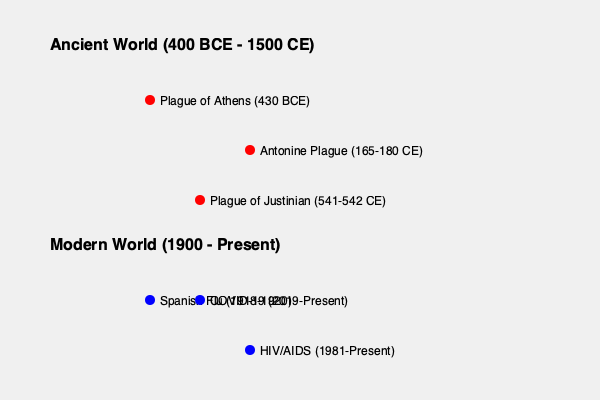Compare the spread of diseases in ancient civilizations to modern pandemics using the world maps provided. What key differences can you identify in terms of geographical reach and speed of transmission? How might these differences be explained by advancements in biology and technology? 1. Geographical reach:
   - Ancient diseases: Primarily concentrated in specific regions (e.g., Athens, Roman Empire, Byzantine Empire)
   - Modern pandemics: Global spread across multiple continents

2. Speed of transmission:
   - Ancient diseases: Slower spread due to limited transportation and communication
   - Modern pandemics: Rapid spread facilitated by air travel and global interconnectedness

3. Biological advancements:
   - Understanding of pathogens: Ancient civilizations lacked knowledge of microorganisms, while modern science has identified specific viruses and bacteria
   - Diagnostic tools: Modern technology allows for rapid identification and tracking of diseases

4. Technological advancements:
   - Transportation: Modern air travel enables pathogens to spread across continents within hours
   - Communication: Global health networks and real-time data sharing allow for faster response and containment efforts

5. Population dynamics:
   - Urbanization: Increased population density in modern cities facilitates disease transmission
   - Global population: Larger, more interconnected global population provides more hosts for pathogens

6. Medical advancements:
   - Treatments: Development of antibiotics, antivirals, and vaccines in the modern era
   - Healthcare systems: Improved sanitation, hygiene practices, and medical infrastructure

7. Surveillance and monitoring:
   - Ancient: Limited to observable symptoms and local reports
   - Modern: Advanced epidemiological tools, genetic sequencing, and global health organizations (e.g., WHO)

The key differences in disease spread between ancient and modern times can be attributed to advancements in biological understanding, technological capabilities, and global interconnectedness. While these factors have improved our ability to respond to pandemics, they have also created new challenges in preventing and controlling the rapid spread of diseases on a global scale.
Answer: Modern pandemics spread faster and more globally due to advanced transportation, increased population density, and global interconnectedness, while improved biological knowledge and technology enable better detection, monitoring, and response capabilities. 